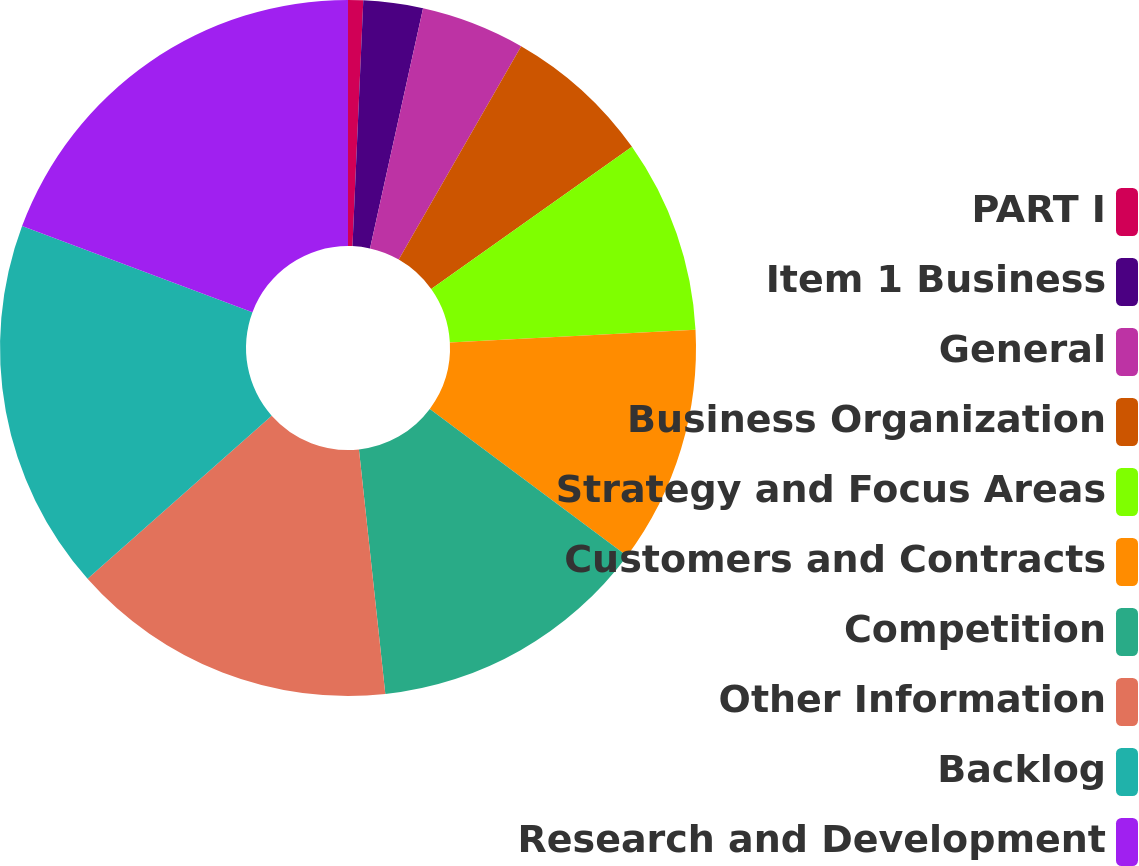Convert chart. <chart><loc_0><loc_0><loc_500><loc_500><pie_chart><fcel>PART I<fcel>Item 1 Business<fcel>General<fcel>Business Organization<fcel>Strategy and Focus Areas<fcel>Customers and Contracts<fcel>Competition<fcel>Other Information<fcel>Backlog<fcel>Research and Development<nl><fcel>0.7%<fcel>2.76%<fcel>4.83%<fcel>6.9%<fcel>8.97%<fcel>11.03%<fcel>13.1%<fcel>15.17%<fcel>17.24%<fcel>19.3%<nl></chart> 